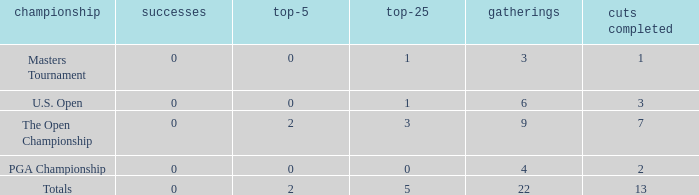What is the fewest number of top-25s for events with more than 13 cuts made? None. 